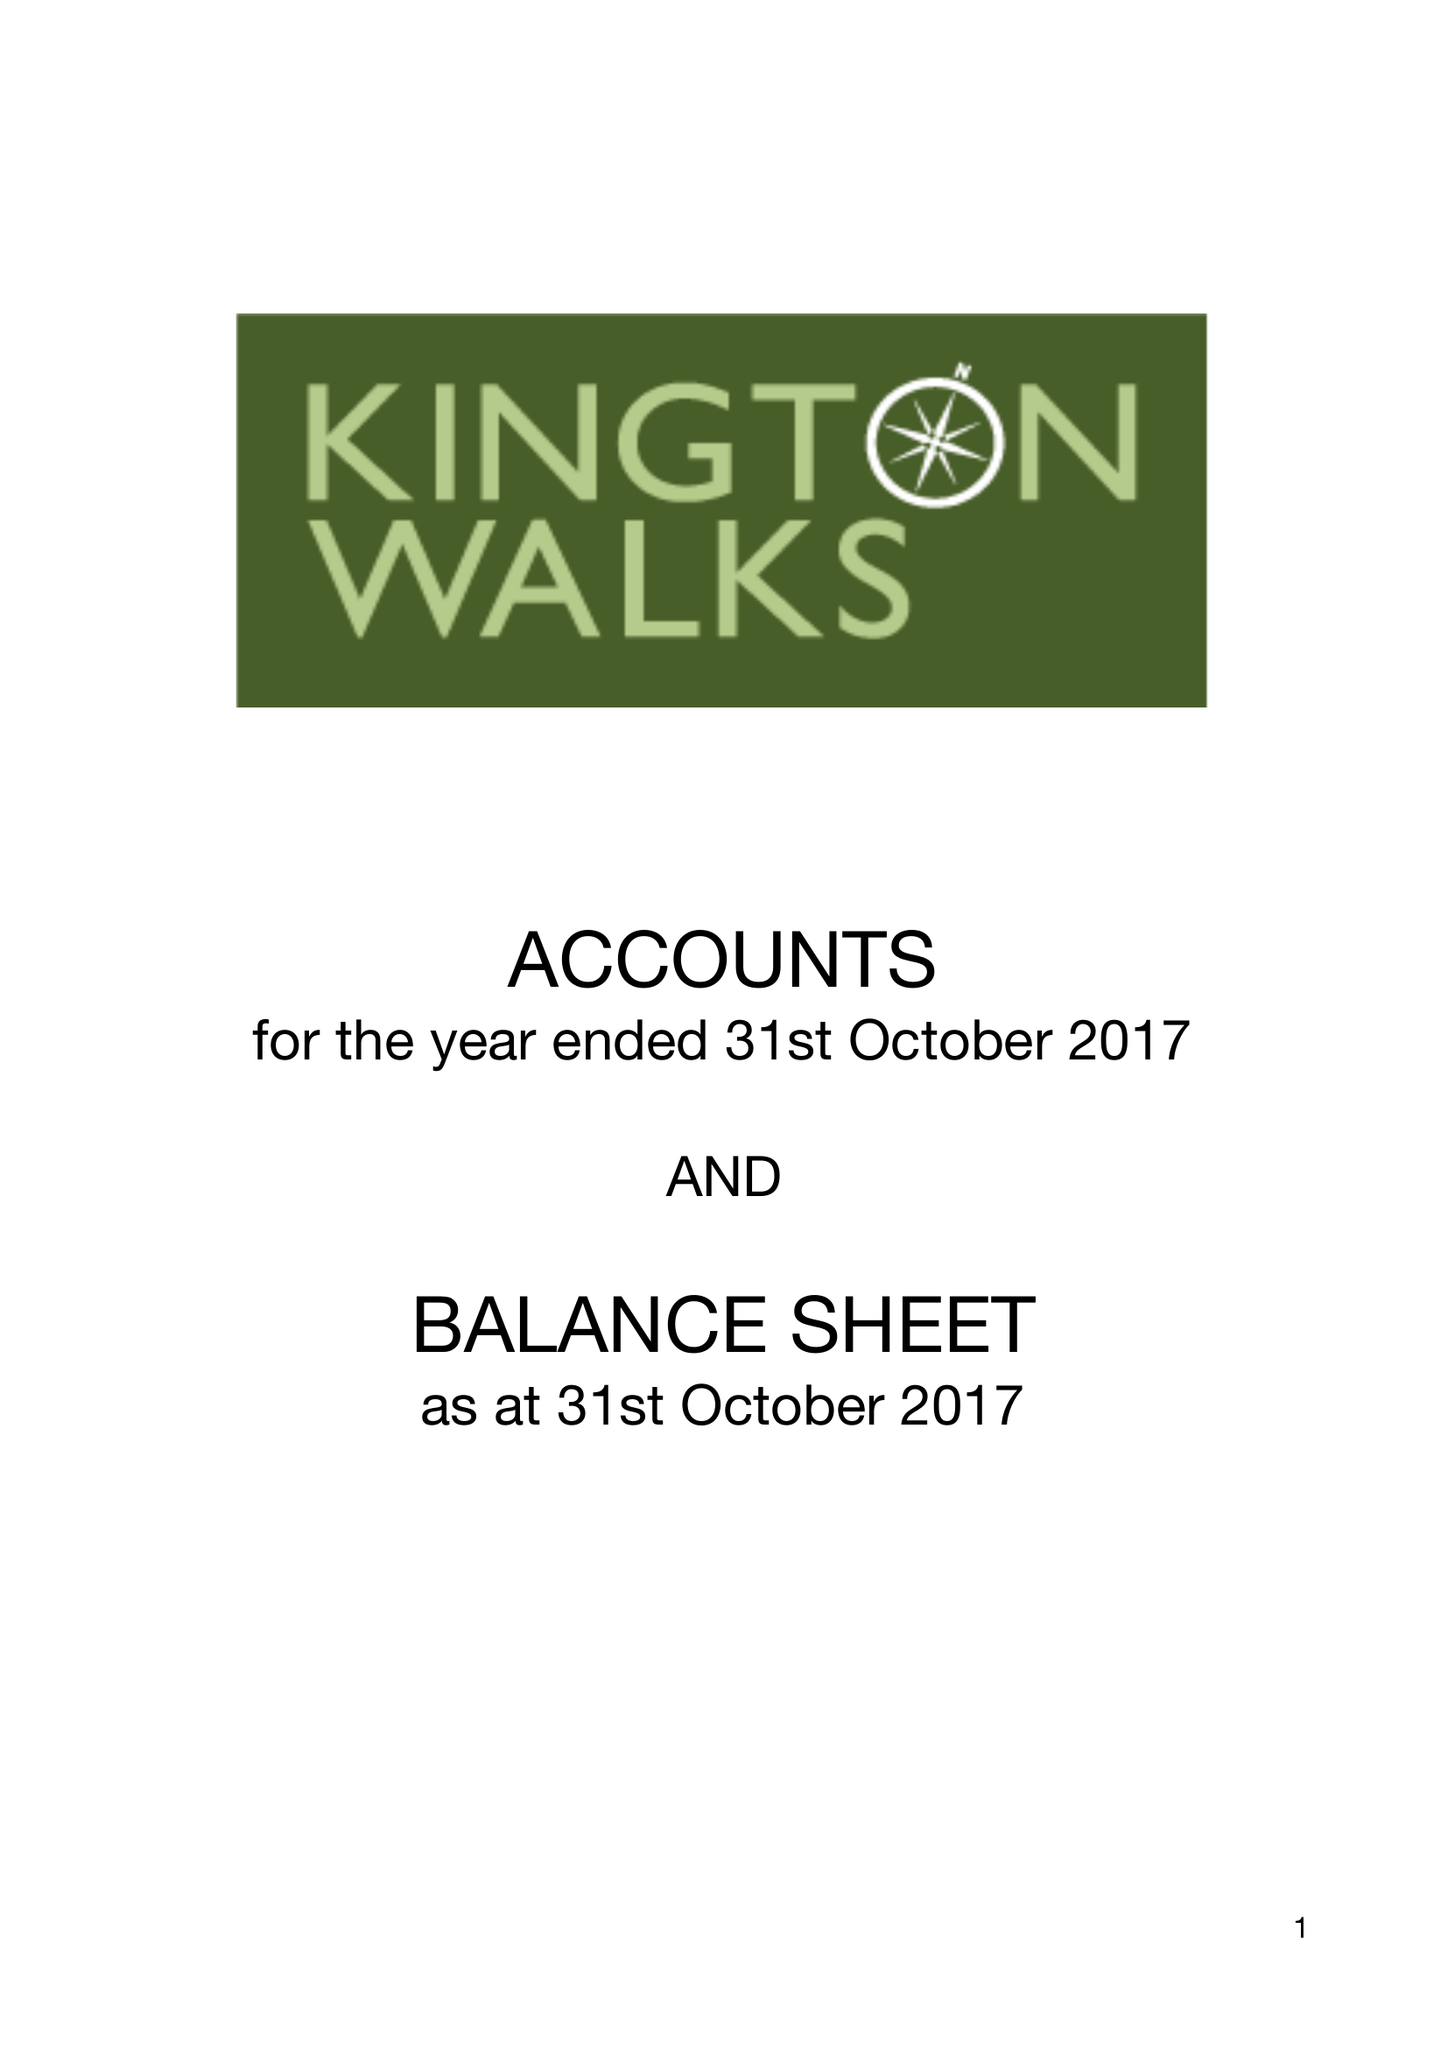What is the value for the address__post_town?
Answer the question using a single word or phrase. KINGTON 